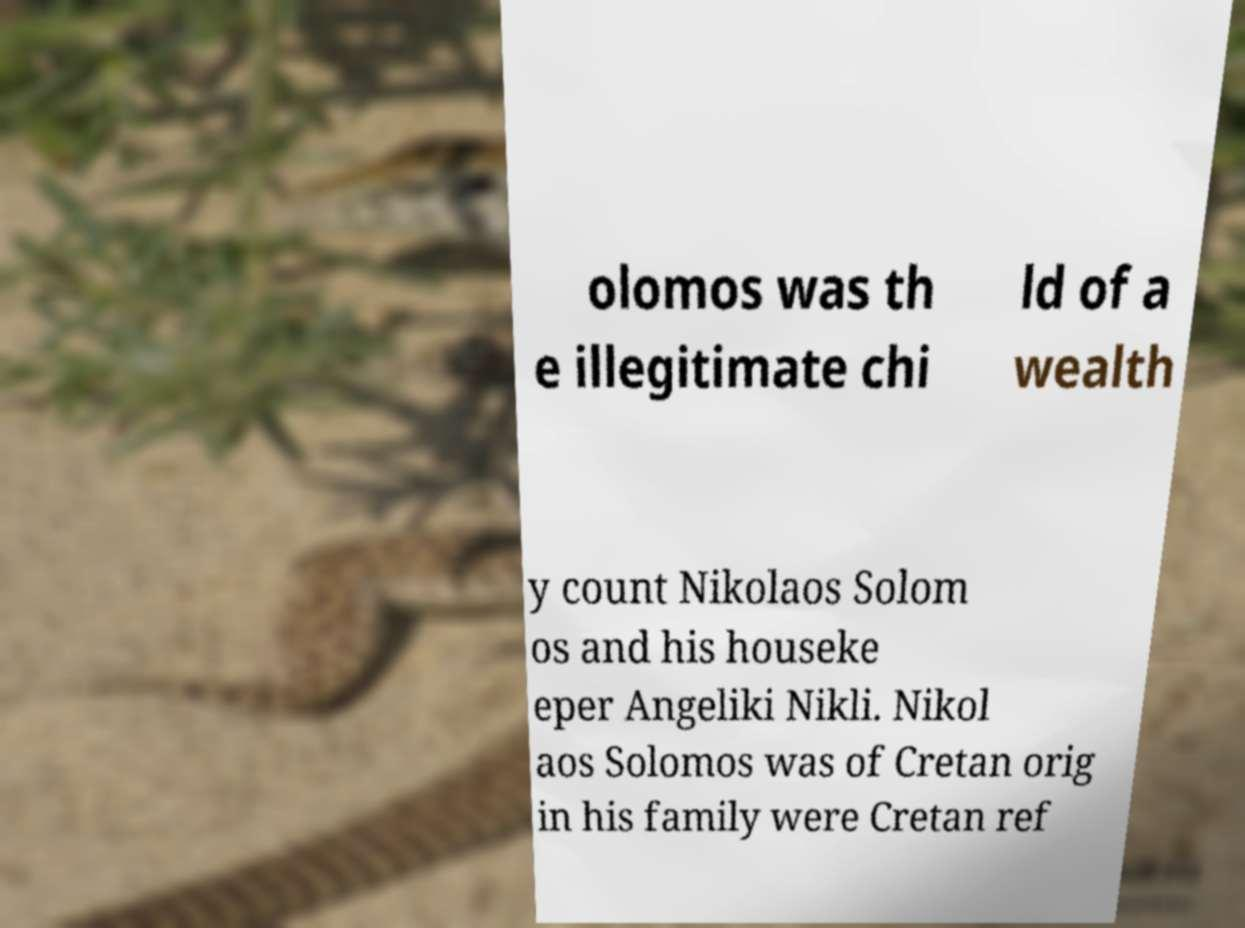Please identify and transcribe the text found in this image. olomos was th e illegitimate chi ld of a wealth y count Nikolaos Solom os and his houseke eper Angeliki Nikli. Nikol aos Solomos was of Cretan orig in his family were Cretan ref 